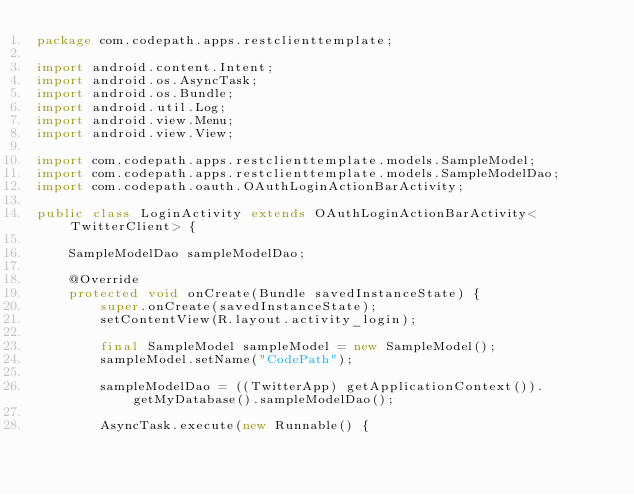Convert code to text. <code><loc_0><loc_0><loc_500><loc_500><_Java_>package com.codepath.apps.restclienttemplate;

import android.content.Intent;
import android.os.AsyncTask;
import android.os.Bundle;
import android.util.Log;
import android.view.Menu;
import android.view.View;

import com.codepath.apps.restclienttemplate.models.SampleModel;
import com.codepath.apps.restclienttemplate.models.SampleModelDao;
import com.codepath.oauth.OAuthLoginActionBarActivity;

public class LoginActivity extends OAuthLoginActionBarActivity<TwitterClient> {

	SampleModelDao sampleModelDao;
	
	@Override
	protected void onCreate(Bundle savedInstanceState) {
		super.onCreate(savedInstanceState);
		setContentView(R.layout.activity_login);

		final SampleModel sampleModel = new SampleModel();
		sampleModel.setName("CodePath");

		sampleModelDao = ((TwitterApp) getApplicationContext()).getMyDatabase().sampleModelDao();

		AsyncTask.execute(new Runnable() {</code> 